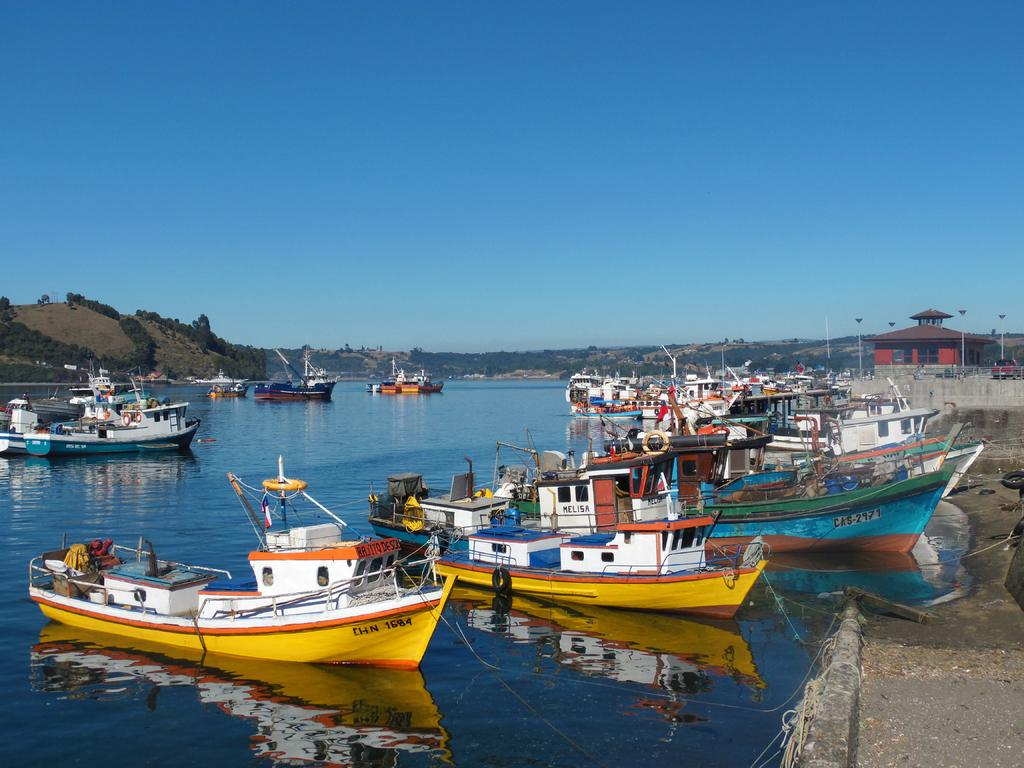What is in the water in the image? There are boats in the water in the image. What can be seen in the background of the image? There are trees, poles, and the sky visible in the background of the image. Where is the building located in the image? The building is on the right side of the image. Can you tell me how many squirrels are climbing the poles in the image? There are no squirrels present in the image; the poles are in the background without any animals visible. 